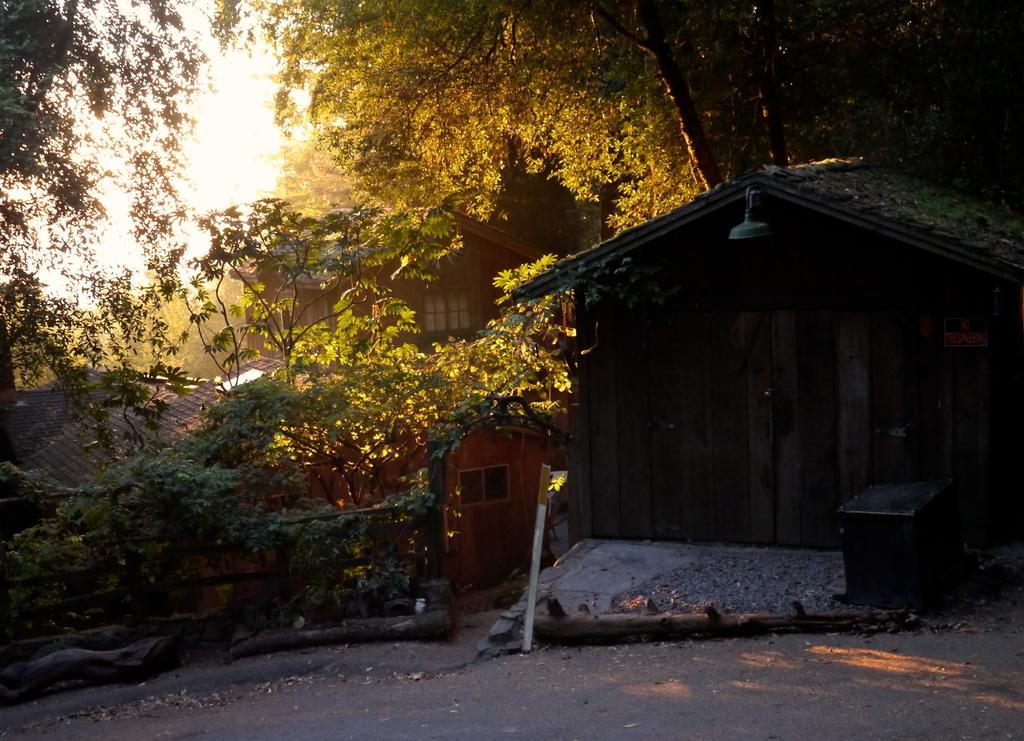Please provide a concise description of this image. In this picture we can see a room on the right side, there are some trees here, we can see the sky at the top of the picture, we can see some wood here. 